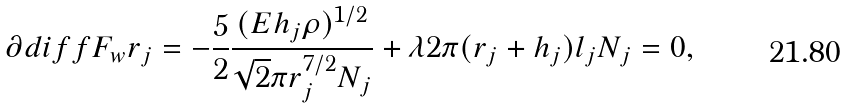Convert formula to latex. <formula><loc_0><loc_0><loc_500><loc_500>\partial d i f f { F _ { w } } { r _ { j } } = - \frac { 5 } { 2 } \frac { ( E h _ { j } \rho ) ^ { 1 / 2 } } { \sqrt { 2 } \pi r _ { j } ^ { 7 / 2 } N _ { j } } + \lambda 2 \pi ( r _ { j } + h _ { j } ) l _ { j } N _ { j } = 0 ,</formula> 